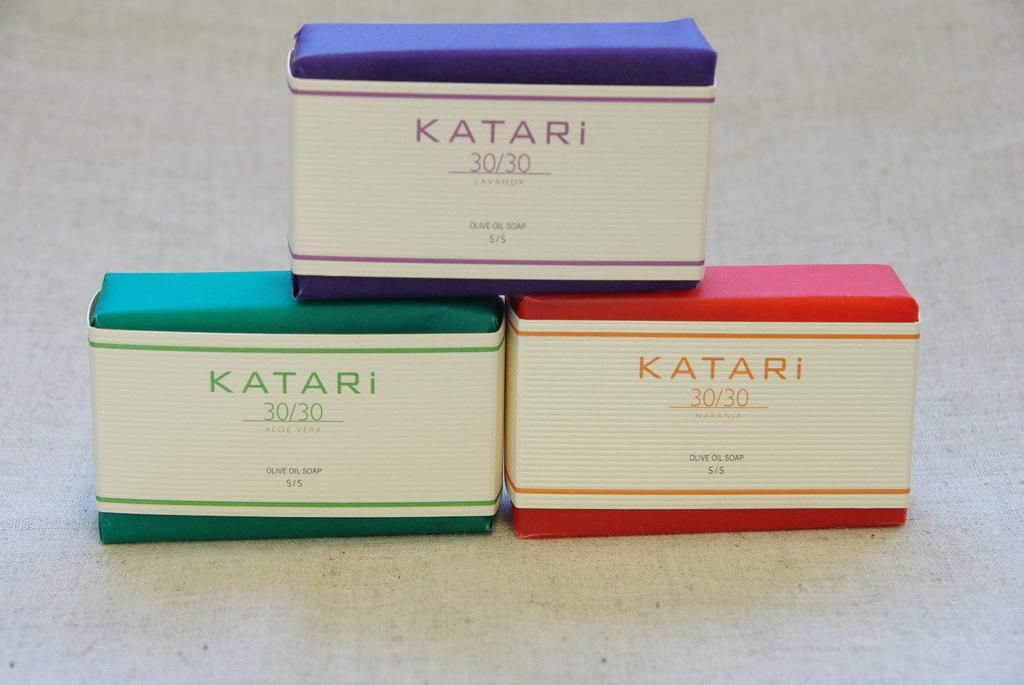What type of furniture is present in the image? There is a table in the image. What objects are placed on the table? There are boxes on the table. What can be seen on the boxes? There is text on the boxes. How does the table limit the view of the room in the image? The table does not limit the view of the room in the image; it is just one piece of furniture among others that might be present. 